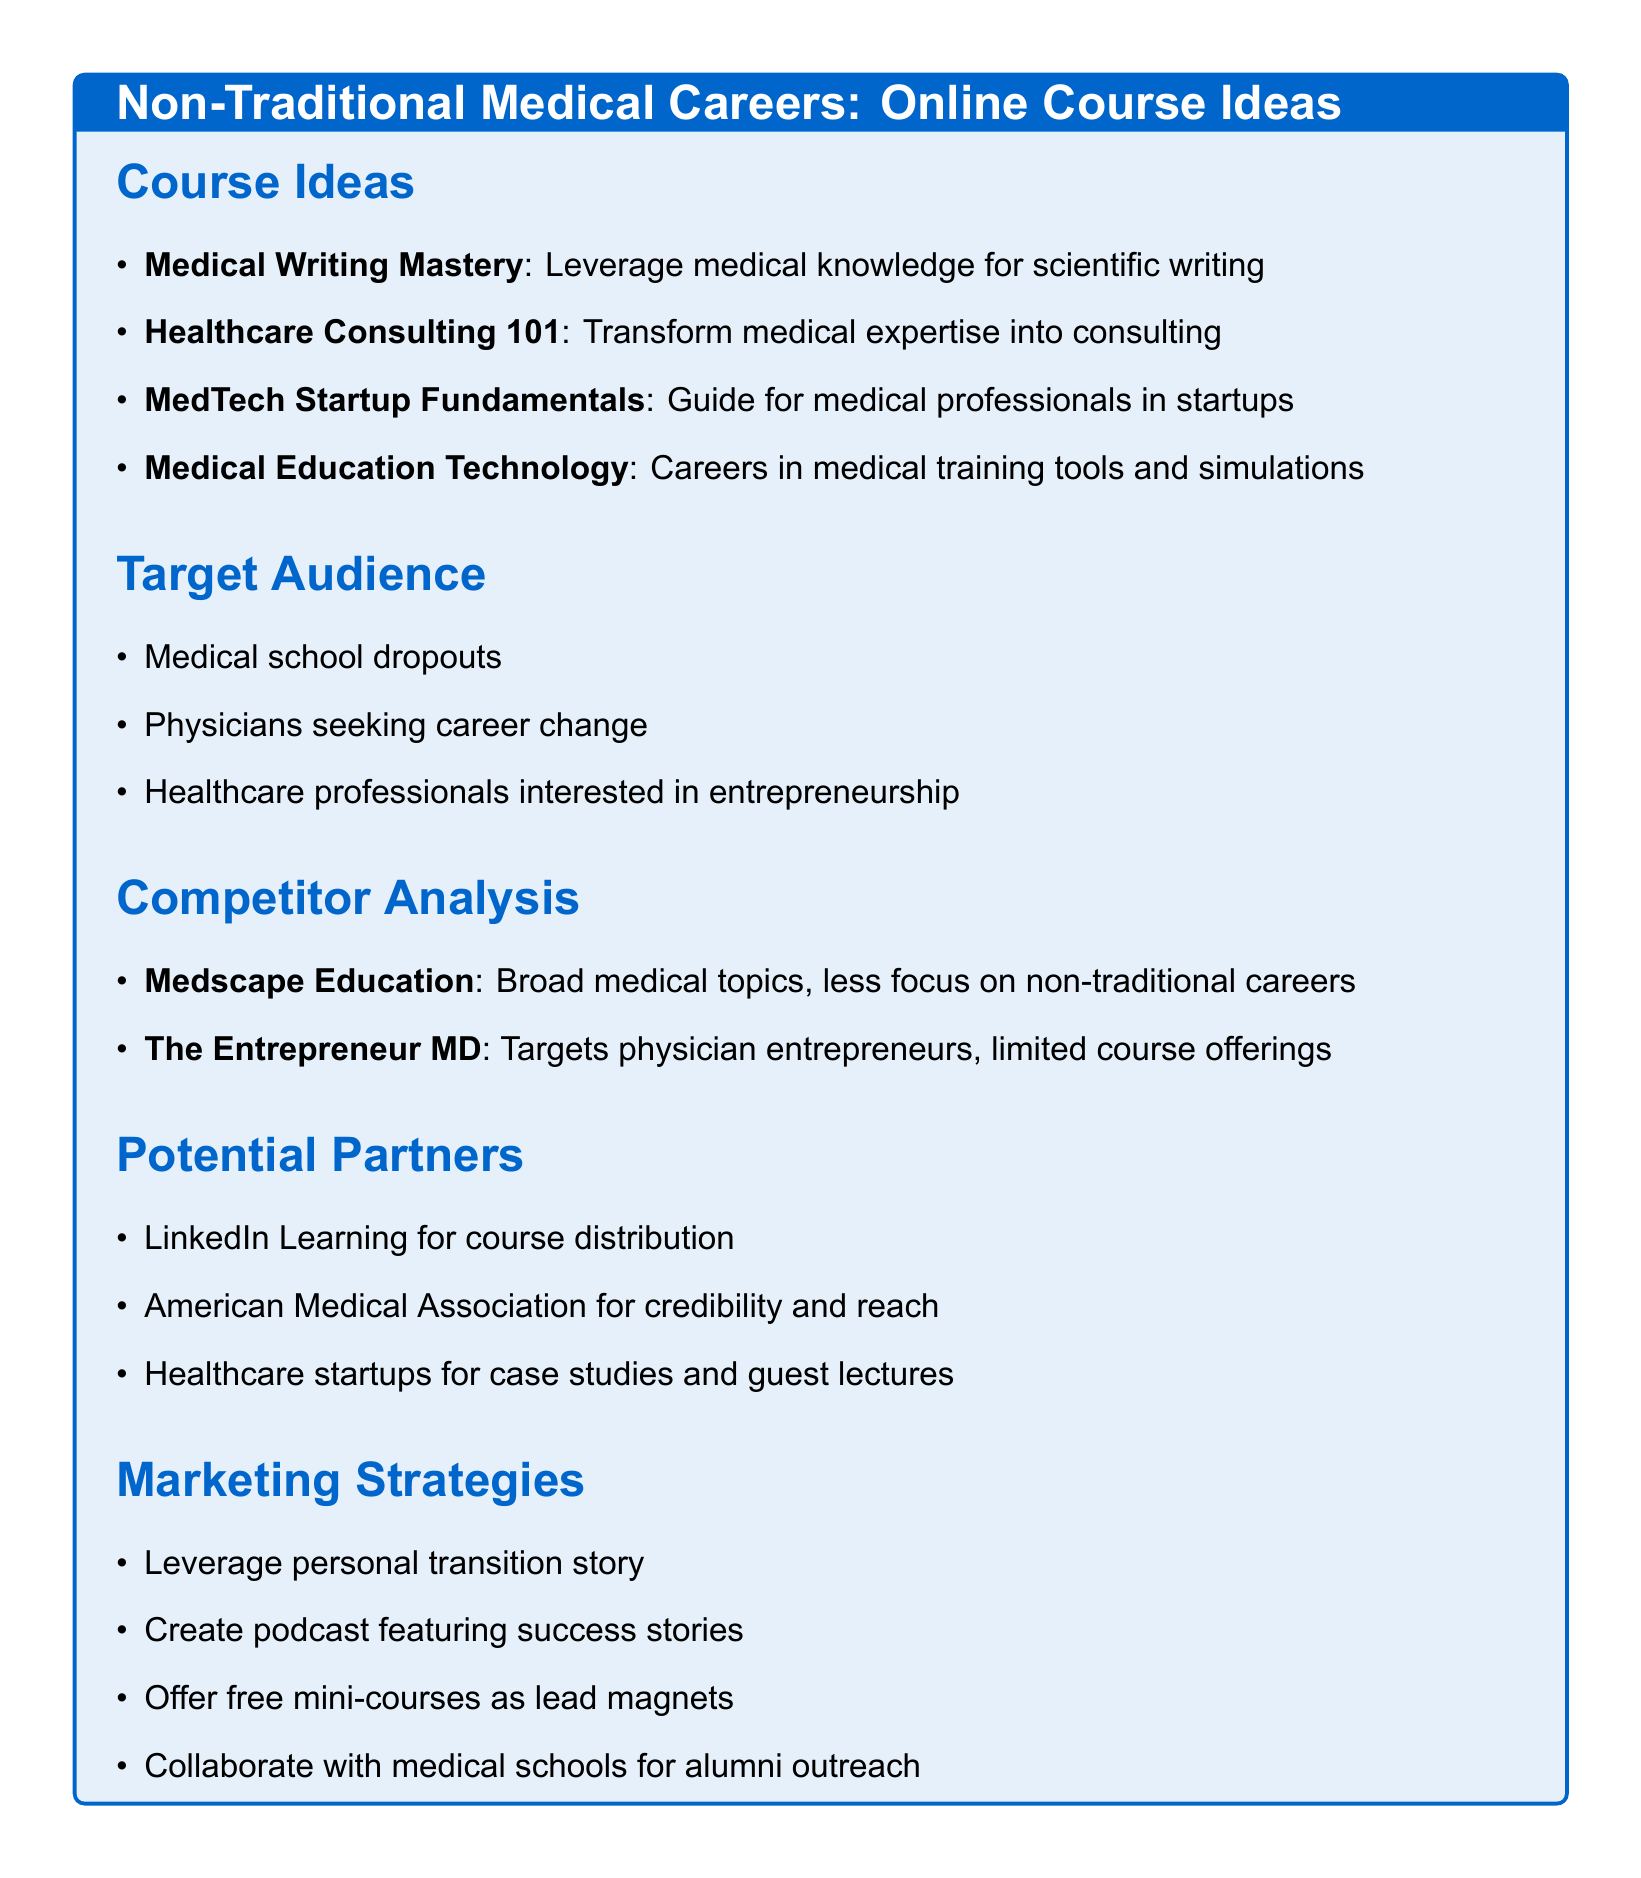What is the title of the course focused on medical writing? The title is specifically mentioned in the course ideas section dedicated to medical writing.
Answer: Medical Writing Mastery What module is included in the Healthcare Consulting 101 course? This is an example of a module listed under the potential modules for the Healthcare Consulting 101 course.
Answer: Basics of healthcare systems and policies Who is a potential partner for credibility and reach? The document lists potential partners for course development, including organizations that can enhance credibility.
Answer: American Medical Association What is a marketing strategy listed in the document? The document outlines various marketing strategies that can help promote the courses.
Answer: Offer free mini-courses as lead magnets How many course ideas are presented in the document? The document includes a specific number of course ideas listed in the Course Ideas section.
Answer: Four 